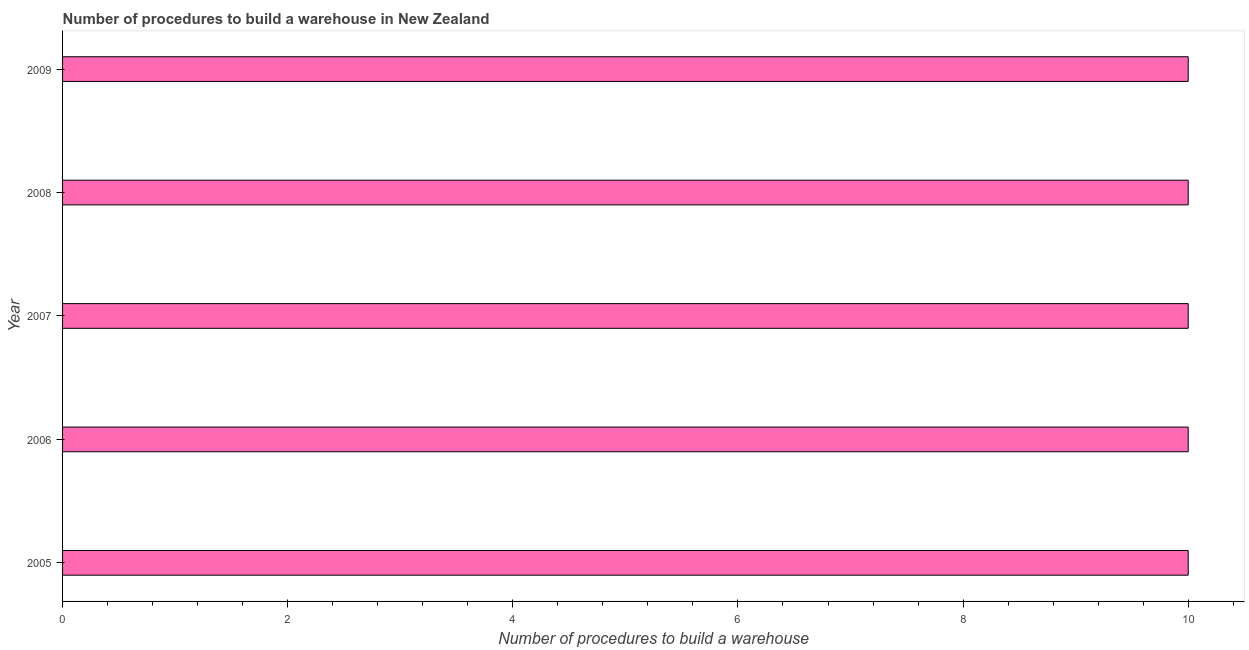Does the graph contain any zero values?
Your answer should be compact. No. What is the title of the graph?
Your answer should be very brief. Number of procedures to build a warehouse in New Zealand. What is the label or title of the X-axis?
Ensure brevity in your answer.  Number of procedures to build a warehouse. What is the number of procedures to build a warehouse in 2009?
Keep it short and to the point. 10. Across all years, what is the maximum number of procedures to build a warehouse?
Keep it short and to the point. 10. In which year was the number of procedures to build a warehouse maximum?
Ensure brevity in your answer.  2005. In which year was the number of procedures to build a warehouse minimum?
Provide a short and direct response. 2005. What is the sum of the number of procedures to build a warehouse?
Offer a terse response. 50. What is the average number of procedures to build a warehouse per year?
Provide a short and direct response. 10. What is the median number of procedures to build a warehouse?
Ensure brevity in your answer.  10. Do a majority of the years between 2008 and 2007 (inclusive) have number of procedures to build a warehouse greater than 3.6 ?
Keep it short and to the point. No. Is the number of procedures to build a warehouse in 2005 less than that in 2007?
Make the answer very short. No. Is the difference between the number of procedures to build a warehouse in 2006 and 2008 greater than the difference between any two years?
Offer a terse response. Yes. How many bars are there?
Your answer should be compact. 5. How many years are there in the graph?
Your answer should be very brief. 5. What is the Number of procedures to build a warehouse of 2005?
Keep it short and to the point. 10. What is the Number of procedures to build a warehouse in 2006?
Make the answer very short. 10. What is the Number of procedures to build a warehouse in 2007?
Your response must be concise. 10. What is the Number of procedures to build a warehouse in 2008?
Offer a terse response. 10. What is the difference between the Number of procedures to build a warehouse in 2005 and 2007?
Keep it short and to the point. 0. What is the difference between the Number of procedures to build a warehouse in 2005 and 2008?
Offer a very short reply. 0. What is the difference between the Number of procedures to build a warehouse in 2005 and 2009?
Make the answer very short. 0. What is the difference between the Number of procedures to build a warehouse in 2006 and 2008?
Ensure brevity in your answer.  0. What is the difference between the Number of procedures to build a warehouse in 2007 and 2008?
Give a very brief answer. 0. What is the difference between the Number of procedures to build a warehouse in 2007 and 2009?
Offer a terse response. 0. What is the ratio of the Number of procedures to build a warehouse in 2005 to that in 2007?
Provide a succinct answer. 1. What is the ratio of the Number of procedures to build a warehouse in 2005 to that in 2008?
Give a very brief answer. 1. What is the ratio of the Number of procedures to build a warehouse in 2005 to that in 2009?
Give a very brief answer. 1. What is the ratio of the Number of procedures to build a warehouse in 2006 to that in 2007?
Ensure brevity in your answer.  1. What is the ratio of the Number of procedures to build a warehouse in 2006 to that in 2008?
Provide a short and direct response. 1. What is the ratio of the Number of procedures to build a warehouse in 2007 to that in 2008?
Keep it short and to the point. 1. What is the ratio of the Number of procedures to build a warehouse in 2007 to that in 2009?
Provide a succinct answer. 1. What is the ratio of the Number of procedures to build a warehouse in 2008 to that in 2009?
Give a very brief answer. 1. 